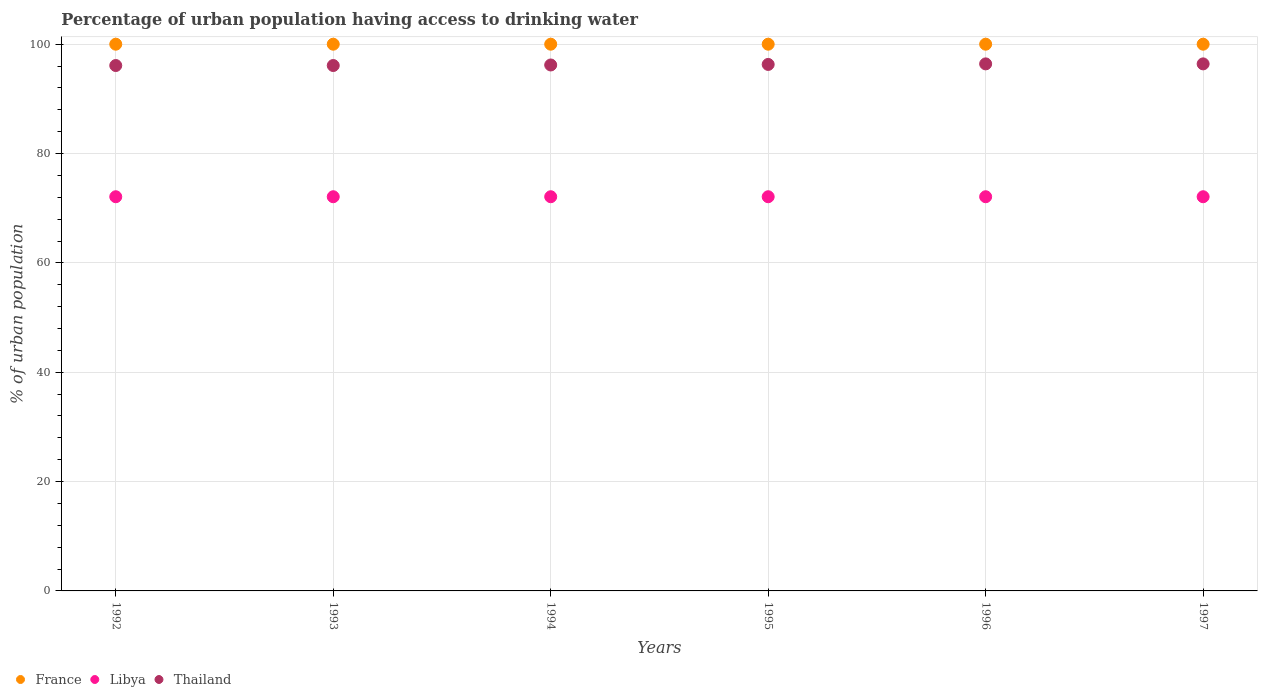What is the percentage of urban population having access to drinking water in France in 1997?
Give a very brief answer. 100. Across all years, what is the maximum percentage of urban population having access to drinking water in France?
Offer a very short reply. 100. Across all years, what is the minimum percentage of urban population having access to drinking water in France?
Provide a short and direct response. 100. In which year was the percentage of urban population having access to drinking water in Thailand minimum?
Offer a very short reply. 1992. What is the total percentage of urban population having access to drinking water in France in the graph?
Offer a terse response. 600. What is the difference between the percentage of urban population having access to drinking water in Libya in 1994 and that in 1996?
Offer a terse response. 0. What is the difference between the percentage of urban population having access to drinking water in Libya in 1995 and the percentage of urban population having access to drinking water in France in 1996?
Your answer should be compact. -27.9. In the year 1992, what is the difference between the percentage of urban population having access to drinking water in France and percentage of urban population having access to drinking water in Thailand?
Your response must be concise. 3.9. What is the difference between the highest and the second highest percentage of urban population having access to drinking water in France?
Ensure brevity in your answer.  0. Is it the case that in every year, the sum of the percentage of urban population having access to drinking water in France and percentage of urban population having access to drinking water in Thailand  is greater than the percentage of urban population having access to drinking water in Libya?
Your answer should be very brief. Yes. Is the percentage of urban population having access to drinking water in Thailand strictly greater than the percentage of urban population having access to drinking water in Libya over the years?
Provide a short and direct response. Yes. Is the percentage of urban population having access to drinking water in Thailand strictly less than the percentage of urban population having access to drinking water in France over the years?
Provide a short and direct response. Yes. How many dotlines are there?
Your answer should be very brief. 3. Does the graph contain any zero values?
Ensure brevity in your answer.  No. Where does the legend appear in the graph?
Your response must be concise. Bottom left. How are the legend labels stacked?
Keep it short and to the point. Horizontal. What is the title of the graph?
Your response must be concise. Percentage of urban population having access to drinking water. What is the label or title of the X-axis?
Offer a very short reply. Years. What is the label or title of the Y-axis?
Keep it short and to the point. % of urban population. What is the % of urban population of France in 1992?
Offer a very short reply. 100. What is the % of urban population of Libya in 1992?
Make the answer very short. 72.1. What is the % of urban population in Thailand in 1992?
Your response must be concise. 96.1. What is the % of urban population of Libya in 1993?
Provide a short and direct response. 72.1. What is the % of urban population in Thailand in 1993?
Offer a terse response. 96.1. What is the % of urban population of Libya in 1994?
Your response must be concise. 72.1. What is the % of urban population of Thailand in 1994?
Offer a terse response. 96.2. What is the % of urban population in France in 1995?
Offer a very short reply. 100. What is the % of urban population of Libya in 1995?
Offer a very short reply. 72.1. What is the % of urban population in Thailand in 1995?
Make the answer very short. 96.3. What is the % of urban population in Libya in 1996?
Offer a very short reply. 72.1. What is the % of urban population of Thailand in 1996?
Ensure brevity in your answer.  96.4. What is the % of urban population in Libya in 1997?
Make the answer very short. 72.1. What is the % of urban population of Thailand in 1997?
Your answer should be compact. 96.4. Across all years, what is the maximum % of urban population in France?
Your response must be concise. 100. Across all years, what is the maximum % of urban population in Libya?
Your answer should be compact. 72.1. Across all years, what is the maximum % of urban population in Thailand?
Give a very brief answer. 96.4. Across all years, what is the minimum % of urban population in France?
Ensure brevity in your answer.  100. Across all years, what is the minimum % of urban population of Libya?
Ensure brevity in your answer.  72.1. Across all years, what is the minimum % of urban population in Thailand?
Offer a terse response. 96.1. What is the total % of urban population in France in the graph?
Offer a terse response. 600. What is the total % of urban population in Libya in the graph?
Your answer should be compact. 432.6. What is the total % of urban population in Thailand in the graph?
Make the answer very short. 577.5. What is the difference between the % of urban population of France in 1992 and that in 1993?
Provide a short and direct response. 0. What is the difference between the % of urban population in Libya in 1992 and that in 1993?
Your response must be concise. 0. What is the difference between the % of urban population in Thailand in 1992 and that in 1993?
Provide a succinct answer. 0. What is the difference between the % of urban population of France in 1992 and that in 1994?
Your response must be concise. 0. What is the difference between the % of urban population of Thailand in 1992 and that in 1994?
Offer a very short reply. -0.1. What is the difference between the % of urban population of Libya in 1992 and that in 1995?
Offer a very short reply. 0. What is the difference between the % of urban population of Libya in 1992 and that in 1996?
Your response must be concise. 0. What is the difference between the % of urban population of Thailand in 1992 and that in 1996?
Your answer should be compact. -0.3. What is the difference between the % of urban population in Thailand in 1993 and that in 1994?
Offer a very short reply. -0.1. What is the difference between the % of urban population in Libya in 1993 and that in 1995?
Your answer should be very brief. 0. What is the difference between the % of urban population of Thailand in 1993 and that in 1995?
Ensure brevity in your answer.  -0.2. What is the difference between the % of urban population of Libya in 1993 and that in 1996?
Your answer should be very brief. 0. What is the difference between the % of urban population of Thailand in 1993 and that in 1996?
Keep it short and to the point. -0.3. What is the difference between the % of urban population of France in 1993 and that in 1997?
Your response must be concise. 0. What is the difference between the % of urban population in Libya in 1993 and that in 1997?
Your answer should be compact. 0. What is the difference between the % of urban population of Thailand in 1993 and that in 1997?
Provide a short and direct response. -0.3. What is the difference between the % of urban population of France in 1994 and that in 1995?
Provide a succinct answer. 0. What is the difference between the % of urban population in Thailand in 1994 and that in 1995?
Make the answer very short. -0.1. What is the difference between the % of urban population of Libya in 1994 and that in 1996?
Give a very brief answer. 0. What is the difference between the % of urban population of France in 1994 and that in 1997?
Provide a short and direct response. 0. What is the difference between the % of urban population in Libya in 1994 and that in 1997?
Your answer should be compact. 0. What is the difference between the % of urban population in Thailand in 1994 and that in 1997?
Your answer should be very brief. -0.2. What is the difference between the % of urban population in France in 1995 and that in 1996?
Offer a very short reply. 0. What is the difference between the % of urban population of Libya in 1995 and that in 1996?
Keep it short and to the point. 0. What is the difference between the % of urban population of Thailand in 1995 and that in 1996?
Your response must be concise. -0.1. What is the difference between the % of urban population in Thailand in 1995 and that in 1997?
Your answer should be very brief. -0.1. What is the difference between the % of urban population in Libya in 1996 and that in 1997?
Provide a succinct answer. 0. What is the difference between the % of urban population in Thailand in 1996 and that in 1997?
Offer a terse response. 0. What is the difference between the % of urban population in France in 1992 and the % of urban population in Libya in 1993?
Offer a terse response. 27.9. What is the difference between the % of urban population in France in 1992 and the % of urban population in Thailand in 1993?
Ensure brevity in your answer.  3.9. What is the difference between the % of urban population in Libya in 1992 and the % of urban population in Thailand in 1993?
Your response must be concise. -24. What is the difference between the % of urban population of France in 1992 and the % of urban population of Libya in 1994?
Provide a short and direct response. 27.9. What is the difference between the % of urban population in Libya in 1992 and the % of urban population in Thailand in 1994?
Provide a short and direct response. -24.1. What is the difference between the % of urban population of France in 1992 and the % of urban population of Libya in 1995?
Your response must be concise. 27.9. What is the difference between the % of urban population in Libya in 1992 and the % of urban population in Thailand in 1995?
Ensure brevity in your answer.  -24.2. What is the difference between the % of urban population in France in 1992 and the % of urban population in Libya in 1996?
Your answer should be compact. 27.9. What is the difference between the % of urban population of France in 1992 and the % of urban population of Thailand in 1996?
Make the answer very short. 3.6. What is the difference between the % of urban population of Libya in 1992 and the % of urban population of Thailand in 1996?
Make the answer very short. -24.3. What is the difference between the % of urban population in France in 1992 and the % of urban population in Libya in 1997?
Keep it short and to the point. 27.9. What is the difference between the % of urban population in Libya in 1992 and the % of urban population in Thailand in 1997?
Provide a succinct answer. -24.3. What is the difference between the % of urban population of France in 1993 and the % of urban population of Libya in 1994?
Offer a terse response. 27.9. What is the difference between the % of urban population of Libya in 1993 and the % of urban population of Thailand in 1994?
Ensure brevity in your answer.  -24.1. What is the difference between the % of urban population of France in 1993 and the % of urban population of Libya in 1995?
Offer a very short reply. 27.9. What is the difference between the % of urban population in Libya in 1993 and the % of urban population in Thailand in 1995?
Provide a short and direct response. -24.2. What is the difference between the % of urban population in France in 1993 and the % of urban population in Libya in 1996?
Make the answer very short. 27.9. What is the difference between the % of urban population in Libya in 1993 and the % of urban population in Thailand in 1996?
Make the answer very short. -24.3. What is the difference between the % of urban population of France in 1993 and the % of urban population of Libya in 1997?
Your answer should be very brief. 27.9. What is the difference between the % of urban population in Libya in 1993 and the % of urban population in Thailand in 1997?
Give a very brief answer. -24.3. What is the difference between the % of urban population of France in 1994 and the % of urban population of Libya in 1995?
Offer a terse response. 27.9. What is the difference between the % of urban population in France in 1994 and the % of urban population in Thailand in 1995?
Provide a short and direct response. 3.7. What is the difference between the % of urban population of Libya in 1994 and the % of urban population of Thailand in 1995?
Offer a very short reply. -24.2. What is the difference between the % of urban population in France in 1994 and the % of urban population in Libya in 1996?
Give a very brief answer. 27.9. What is the difference between the % of urban population in France in 1994 and the % of urban population in Thailand in 1996?
Provide a succinct answer. 3.6. What is the difference between the % of urban population of Libya in 1994 and the % of urban population of Thailand in 1996?
Your answer should be compact. -24.3. What is the difference between the % of urban population in France in 1994 and the % of urban population in Libya in 1997?
Give a very brief answer. 27.9. What is the difference between the % of urban population of Libya in 1994 and the % of urban population of Thailand in 1997?
Your answer should be compact. -24.3. What is the difference between the % of urban population of France in 1995 and the % of urban population of Libya in 1996?
Provide a succinct answer. 27.9. What is the difference between the % of urban population of France in 1995 and the % of urban population of Thailand in 1996?
Make the answer very short. 3.6. What is the difference between the % of urban population in Libya in 1995 and the % of urban population in Thailand in 1996?
Your answer should be very brief. -24.3. What is the difference between the % of urban population of France in 1995 and the % of urban population of Libya in 1997?
Keep it short and to the point. 27.9. What is the difference between the % of urban population in Libya in 1995 and the % of urban population in Thailand in 1997?
Provide a short and direct response. -24.3. What is the difference between the % of urban population of France in 1996 and the % of urban population of Libya in 1997?
Give a very brief answer. 27.9. What is the difference between the % of urban population in Libya in 1996 and the % of urban population in Thailand in 1997?
Make the answer very short. -24.3. What is the average % of urban population of France per year?
Give a very brief answer. 100. What is the average % of urban population of Libya per year?
Give a very brief answer. 72.1. What is the average % of urban population in Thailand per year?
Make the answer very short. 96.25. In the year 1992, what is the difference between the % of urban population of France and % of urban population of Libya?
Your answer should be compact. 27.9. In the year 1992, what is the difference between the % of urban population of France and % of urban population of Thailand?
Keep it short and to the point. 3.9. In the year 1992, what is the difference between the % of urban population in Libya and % of urban population in Thailand?
Provide a short and direct response. -24. In the year 1993, what is the difference between the % of urban population in France and % of urban population in Libya?
Offer a very short reply. 27.9. In the year 1993, what is the difference between the % of urban population in France and % of urban population in Thailand?
Provide a succinct answer. 3.9. In the year 1994, what is the difference between the % of urban population of France and % of urban population of Libya?
Ensure brevity in your answer.  27.9. In the year 1994, what is the difference between the % of urban population in Libya and % of urban population in Thailand?
Keep it short and to the point. -24.1. In the year 1995, what is the difference between the % of urban population in France and % of urban population in Libya?
Make the answer very short. 27.9. In the year 1995, what is the difference between the % of urban population in France and % of urban population in Thailand?
Offer a terse response. 3.7. In the year 1995, what is the difference between the % of urban population of Libya and % of urban population of Thailand?
Provide a short and direct response. -24.2. In the year 1996, what is the difference between the % of urban population in France and % of urban population in Libya?
Give a very brief answer. 27.9. In the year 1996, what is the difference between the % of urban population in France and % of urban population in Thailand?
Your answer should be very brief. 3.6. In the year 1996, what is the difference between the % of urban population of Libya and % of urban population of Thailand?
Provide a succinct answer. -24.3. In the year 1997, what is the difference between the % of urban population of France and % of urban population of Libya?
Your response must be concise. 27.9. In the year 1997, what is the difference between the % of urban population of France and % of urban population of Thailand?
Your answer should be very brief. 3.6. In the year 1997, what is the difference between the % of urban population in Libya and % of urban population in Thailand?
Give a very brief answer. -24.3. What is the ratio of the % of urban population of Thailand in 1992 to that in 1993?
Give a very brief answer. 1. What is the ratio of the % of urban population of France in 1992 to that in 1994?
Make the answer very short. 1. What is the ratio of the % of urban population of Thailand in 1992 to that in 1994?
Your response must be concise. 1. What is the ratio of the % of urban population of Libya in 1992 to that in 1995?
Offer a terse response. 1. What is the ratio of the % of urban population in Libya in 1992 to that in 1996?
Your answer should be very brief. 1. What is the ratio of the % of urban population of France in 1992 to that in 1997?
Ensure brevity in your answer.  1. What is the ratio of the % of urban population of Thailand in 1992 to that in 1997?
Give a very brief answer. 1. What is the ratio of the % of urban population of Thailand in 1993 to that in 1995?
Make the answer very short. 1. What is the ratio of the % of urban population of France in 1993 to that in 1996?
Provide a succinct answer. 1. What is the ratio of the % of urban population in France in 1993 to that in 1997?
Offer a very short reply. 1. What is the ratio of the % of urban population in France in 1994 to that in 1995?
Keep it short and to the point. 1. What is the ratio of the % of urban population of Libya in 1994 to that in 1995?
Offer a terse response. 1. What is the ratio of the % of urban population in Thailand in 1994 to that in 1995?
Make the answer very short. 1. What is the ratio of the % of urban population in Thailand in 1994 to that in 1996?
Your answer should be compact. 1. What is the ratio of the % of urban population in Thailand in 1994 to that in 1997?
Your response must be concise. 1. What is the ratio of the % of urban population of France in 1996 to that in 1997?
Your answer should be very brief. 1. What is the difference between the highest and the second highest % of urban population of France?
Provide a succinct answer. 0. What is the difference between the highest and the second highest % of urban population of Libya?
Provide a short and direct response. 0. What is the difference between the highest and the lowest % of urban population in Libya?
Provide a short and direct response. 0. 